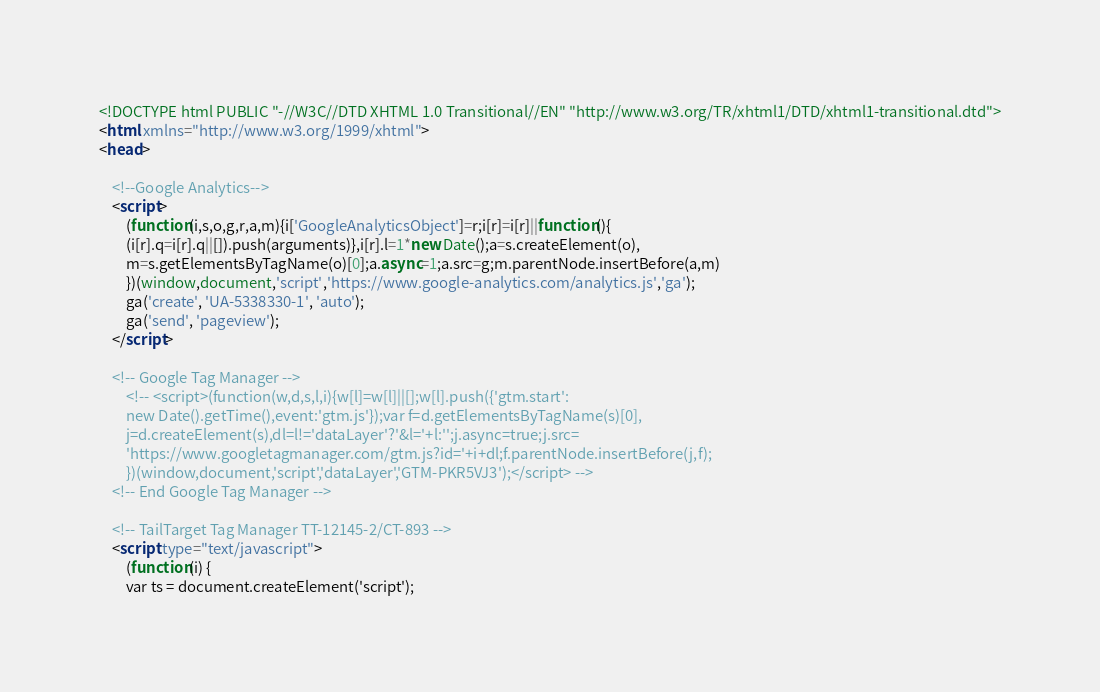Convert code to text. <code><loc_0><loc_0><loc_500><loc_500><_HTML_><!DOCTYPE html PUBLIC "-//W3C//DTD XHTML 1.0 Transitional//EN" "http://www.w3.org/TR/xhtml1/DTD/xhtml1-transitional.dtd">
<html xmlns="http://www.w3.org/1999/xhtml">
<head>

    <!--Google Analytics-->
    <script>
        (function(i,s,o,g,r,a,m){i['GoogleAnalyticsObject']=r;i[r]=i[r]||function(){
        (i[r].q=i[r].q||[]).push(arguments)},i[r].l=1*new Date();a=s.createElement(o),
        m=s.getElementsByTagName(o)[0];a.async=1;a.src=g;m.parentNode.insertBefore(a,m)
        })(window,document,'script','https://www.google-analytics.com/analytics.js','ga');
        ga('create', 'UA-5338330-1', 'auto');
        ga('send', 'pageview');
    </script>

    <!-- Google Tag Manager -->
        <!-- <script>(function(w,d,s,l,i){w[l]=w[l]||[];w[l].push({'gtm.start':
        new Date().getTime(),event:'gtm.js'});var f=d.getElementsByTagName(s)[0],
        j=d.createElement(s),dl=l!='dataLayer'?'&l='+l:'';j.async=true;j.src=
        'https://www.googletagmanager.com/gtm.js?id='+i+dl;f.parentNode.insertBefore(j,f);
        })(window,document,'script','dataLayer','GTM-PKR5VJ3');</script> -->
    <!-- End Google Tag Manager -->

    <!-- TailTarget Tag Manager TT-12145-2/CT-893 --> 
    <script type="text/javascript">
        (function(i) {
        var ts = document.createElement('script');</code> 